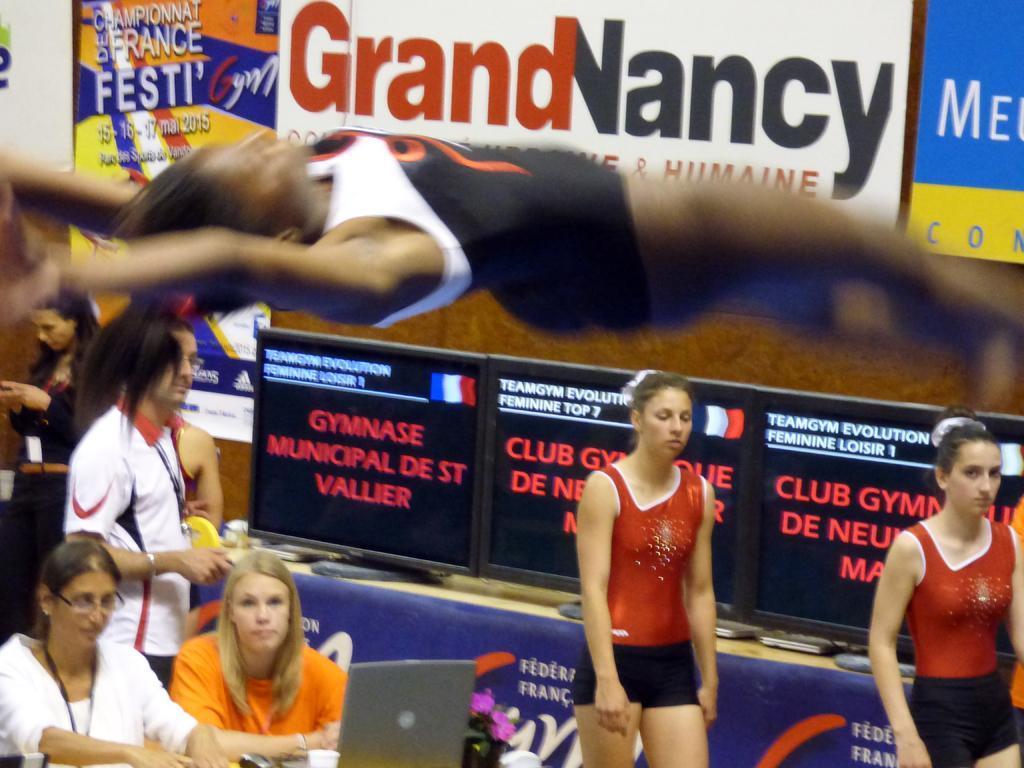In one or two sentences, can you explain what this image depicts? In this picture we can see some people standing, at the left bottom there are two women sitting in front of a table, there is a laptop on the table, on the right side we can see three monitors, in the background there are hoardings. 